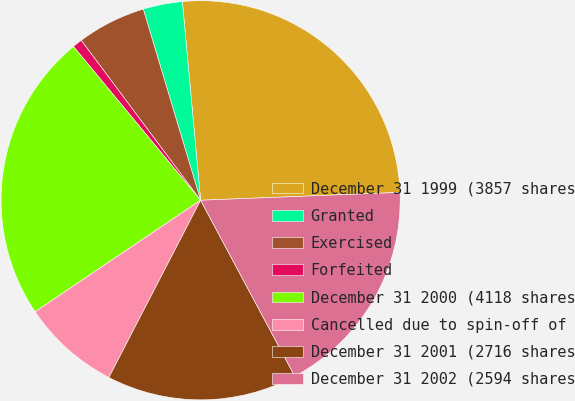Convert chart. <chart><loc_0><loc_0><loc_500><loc_500><pie_chart><fcel>December 31 1999 (3857 shares<fcel>Granted<fcel>Exercised<fcel>Forfeited<fcel>December 31 2000 (4118 shares<fcel>Cancelled due to spin-off of<fcel>December 31 2001 (2716 shares<fcel>December 31 2002 (2594 shares<nl><fcel>25.83%<fcel>3.18%<fcel>5.57%<fcel>0.79%<fcel>23.44%<fcel>7.96%<fcel>15.42%<fcel>17.81%<nl></chart> 